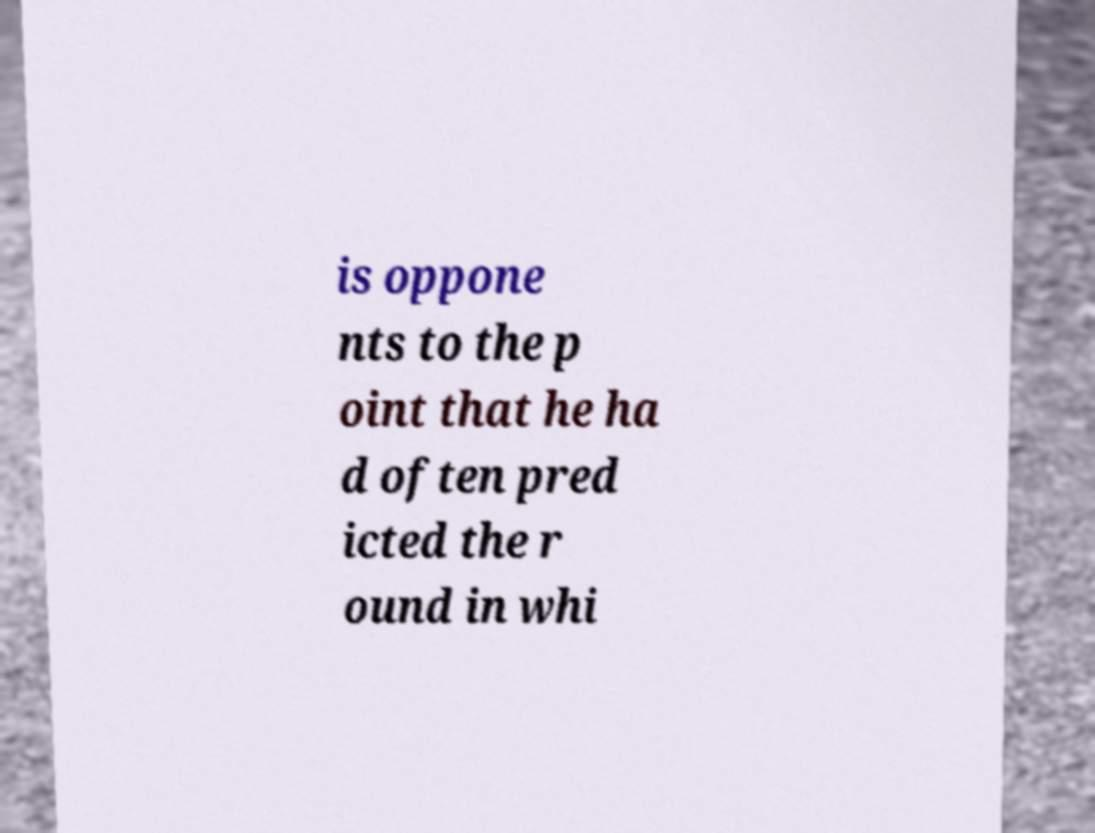Can you read and provide the text displayed in the image?This photo seems to have some interesting text. Can you extract and type it out for me? is oppone nts to the p oint that he ha d often pred icted the r ound in whi 